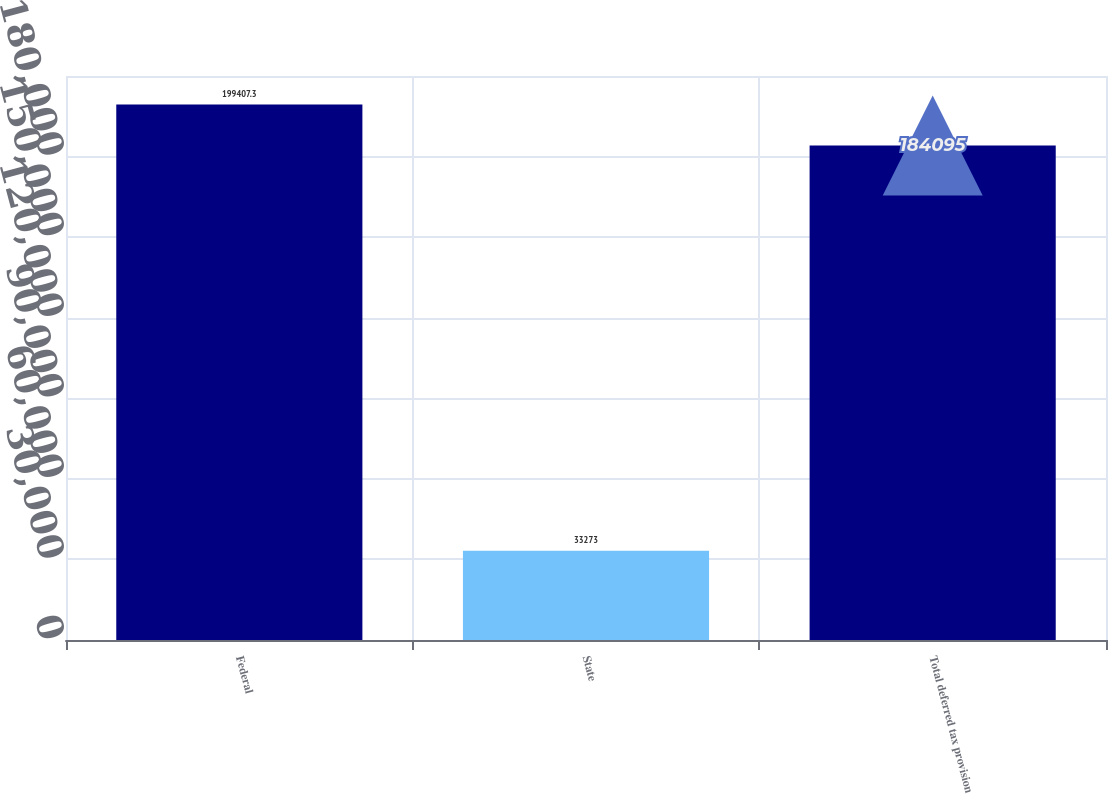Convert chart. <chart><loc_0><loc_0><loc_500><loc_500><bar_chart><fcel>Federal<fcel>State<fcel>Total deferred tax provision<nl><fcel>199407<fcel>33273<fcel>184095<nl></chart> 